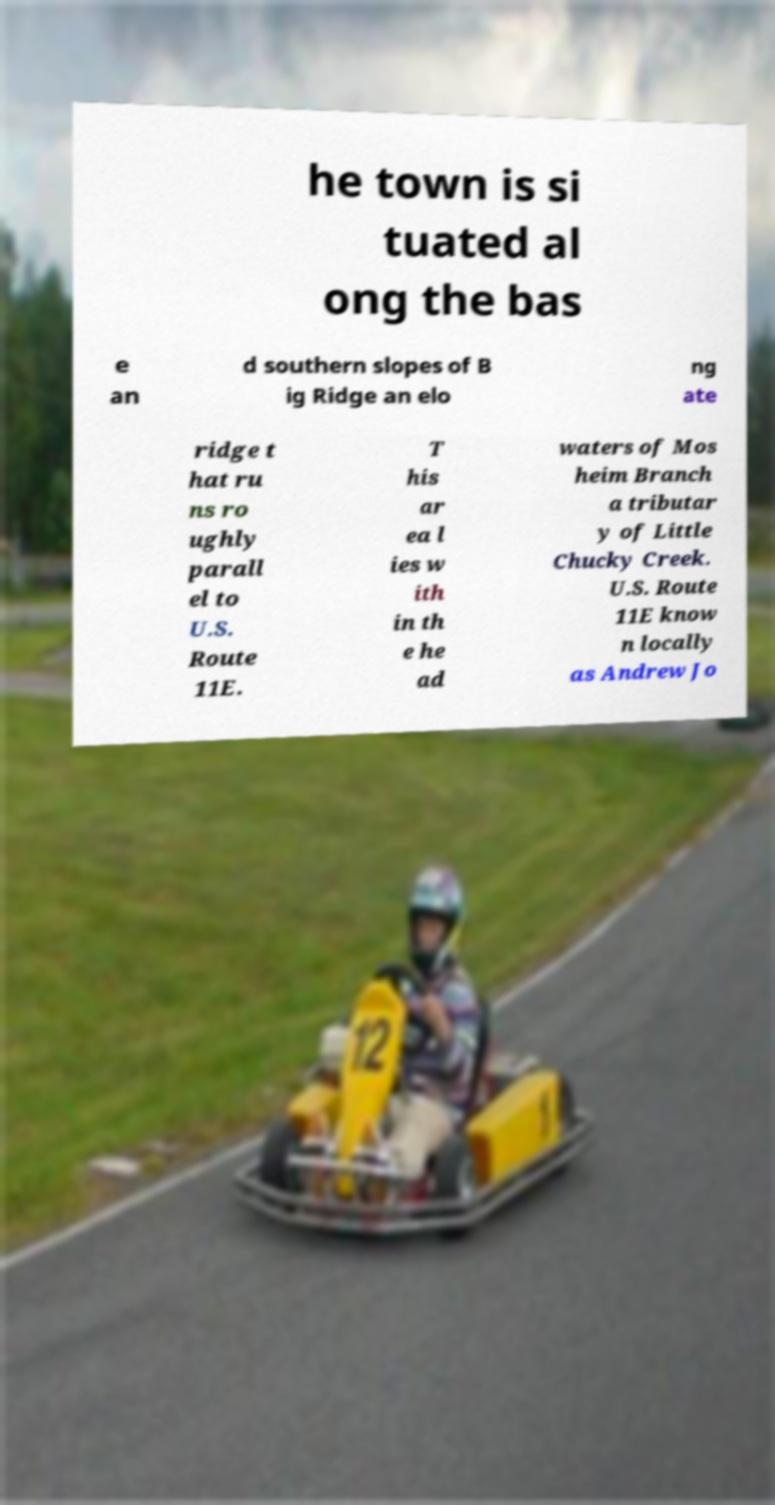There's text embedded in this image that I need extracted. Can you transcribe it verbatim? he town is si tuated al ong the bas e an d southern slopes of B ig Ridge an elo ng ate ridge t hat ru ns ro ughly parall el to U.S. Route 11E. T his ar ea l ies w ith in th e he ad waters of Mos heim Branch a tributar y of Little Chucky Creek. U.S. Route 11E know n locally as Andrew Jo 